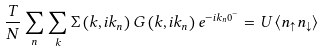<formula> <loc_0><loc_0><loc_500><loc_500>\frac { T } { N } \sum _ { n } \sum _ { k } \Sigma \left ( k , i k _ { n } \right ) G \left ( k , i k _ { n } \right ) e ^ { - i k _ { n } 0 ^ { - } } = U \left \langle n _ { \uparrow } n _ { \downarrow } \right \rangle</formula> 